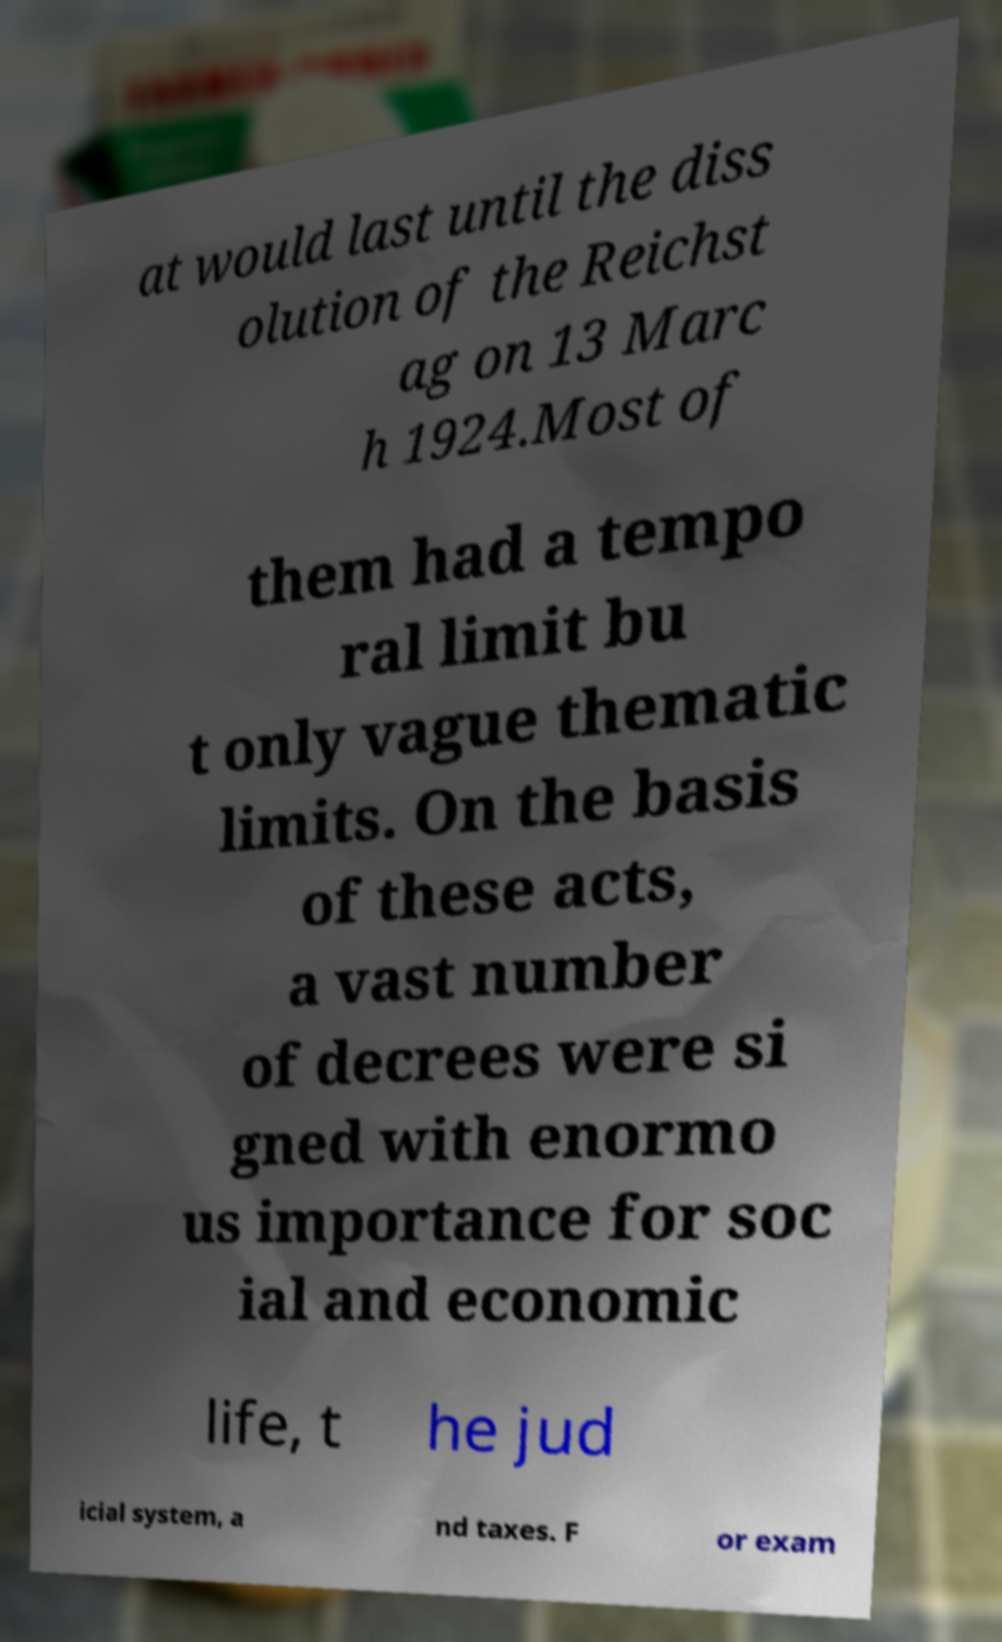Can you accurately transcribe the text from the provided image for me? at would last until the diss olution of the Reichst ag on 13 Marc h 1924.Most of them had a tempo ral limit bu t only vague thematic limits. On the basis of these acts, a vast number of decrees were si gned with enormo us importance for soc ial and economic life, t he jud icial system, a nd taxes. F or exam 